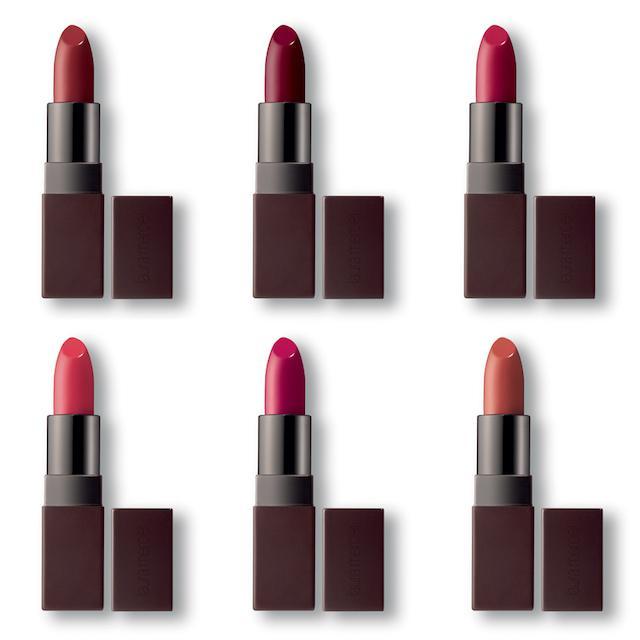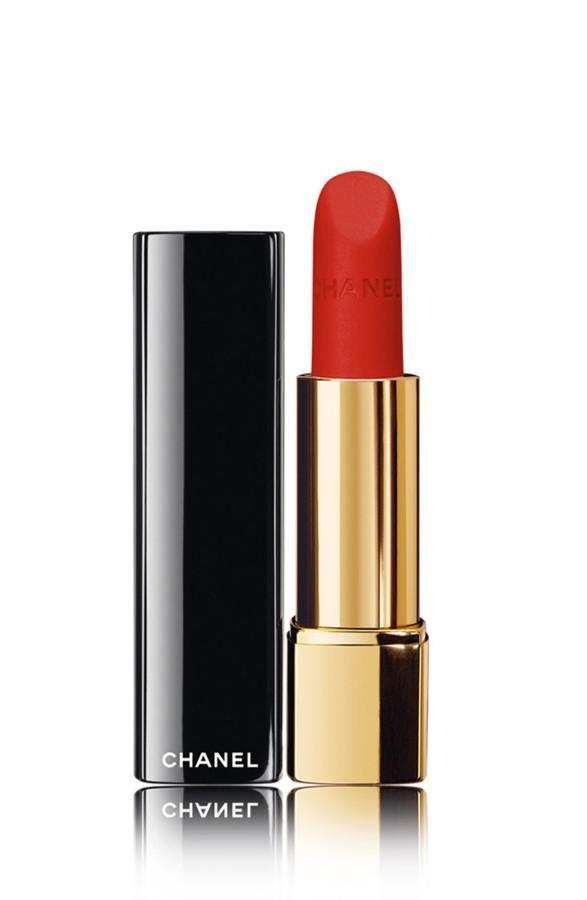The first image is the image on the left, the second image is the image on the right. For the images shown, is this caption "The left image shows at least four traditional lipsticks." true? Answer yes or no. Yes. The first image is the image on the left, the second image is the image on the right. Given the left and right images, does the statement "There are no more than four lipsticks in the image on the left." hold true? Answer yes or no. No. 